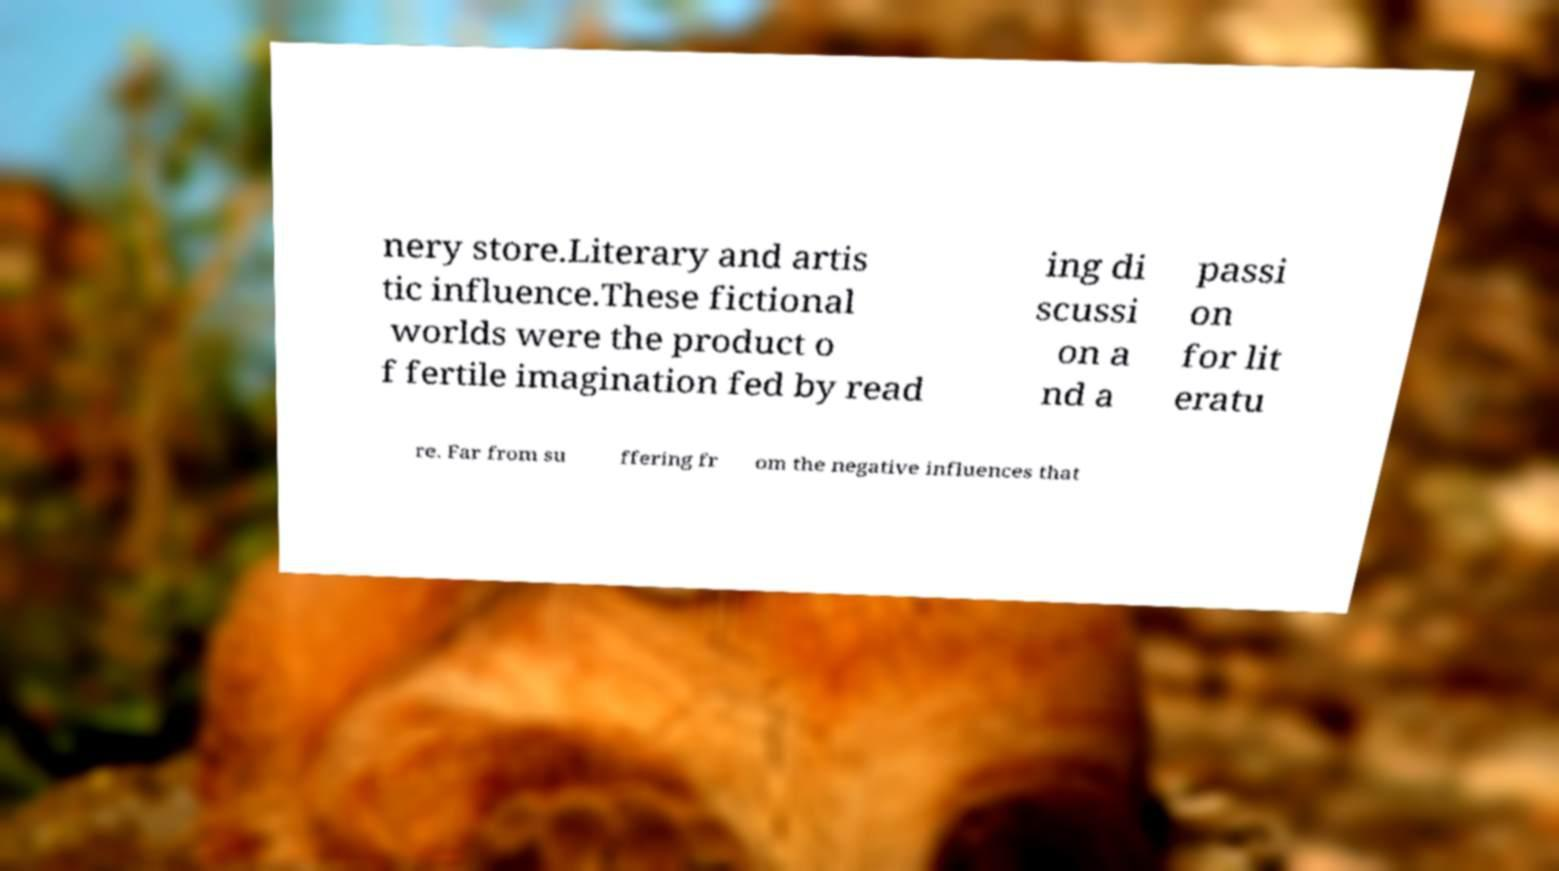Could you extract and type out the text from this image? nery store.Literary and artis tic influence.These fictional worlds were the product o f fertile imagination fed by read ing di scussi on a nd a passi on for lit eratu re. Far from su ffering fr om the negative influences that 